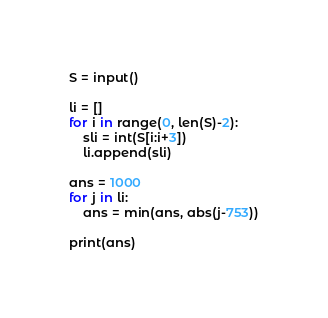<code> <loc_0><loc_0><loc_500><loc_500><_Python_>S = input()

li = []
for i in range(0, len(S)-2):
    sli = int(S[i:i+3])
    li.append(sli)

ans = 1000
for j in li:
    ans = min(ans, abs(j-753))

print(ans)
</code> 